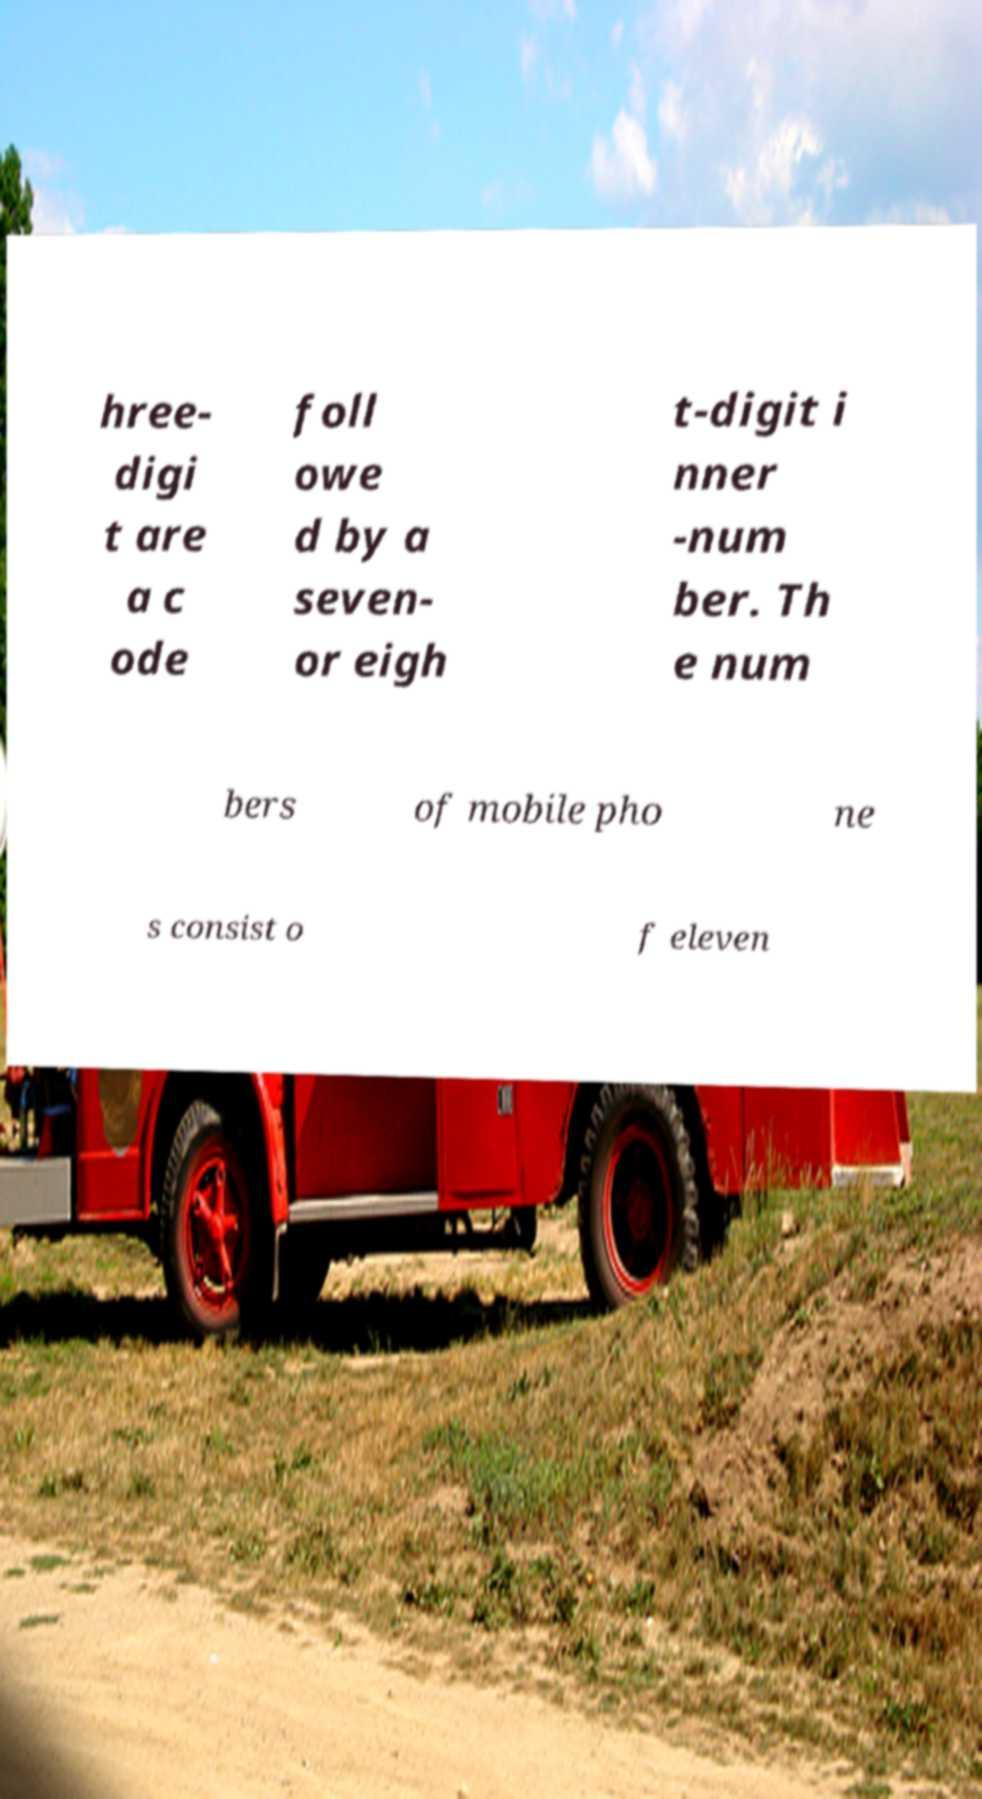Could you assist in decoding the text presented in this image and type it out clearly? hree- digi t are a c ode foll owe d by a seven- or eigh t-digit i nner -num ber. Th e num bers of mobile pho ne s consist o f eleven 